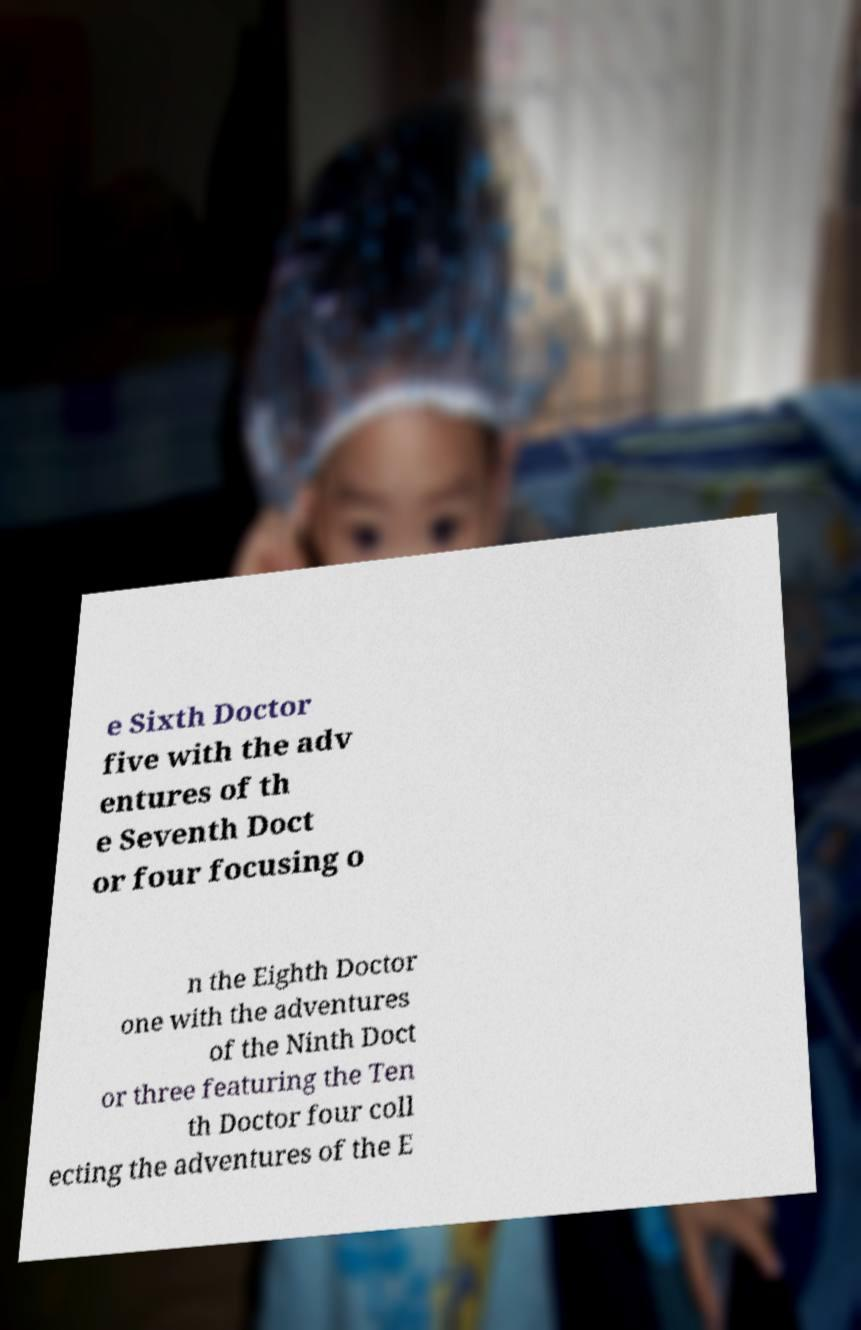Please read and relay the text visible in this image. What does it say? e Sixth Doctor five with the adv entures of th e Seventh Doct or four focusing o n the Eighth Doctor one with the adventures of the Ninth Doct or three featuring the Ten th Doctor four coll ecting the adventures of the E 